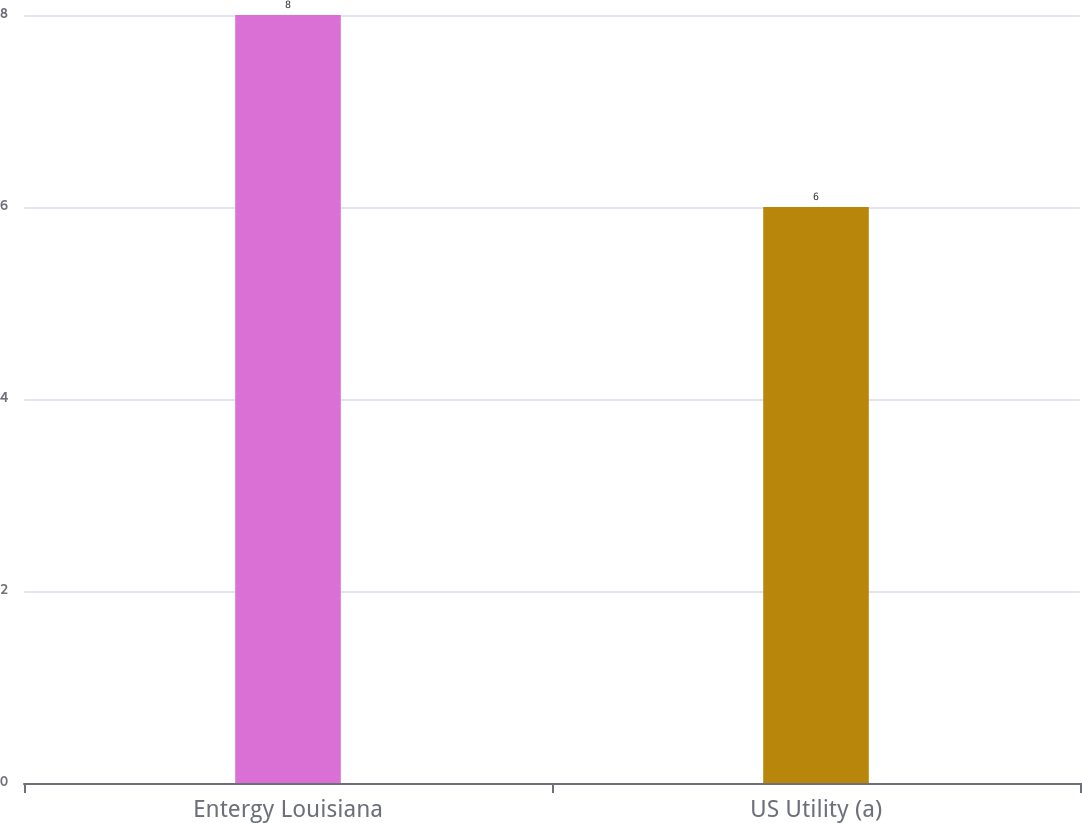Convert chart to OTSL. <chart><loc_0><loc_0><loc_500><loc_500><bar_chart><fcel>Entergy Louisiana<fcel>US Utility (a)<nl><fcel>8<fcel>6<nl></chart> 